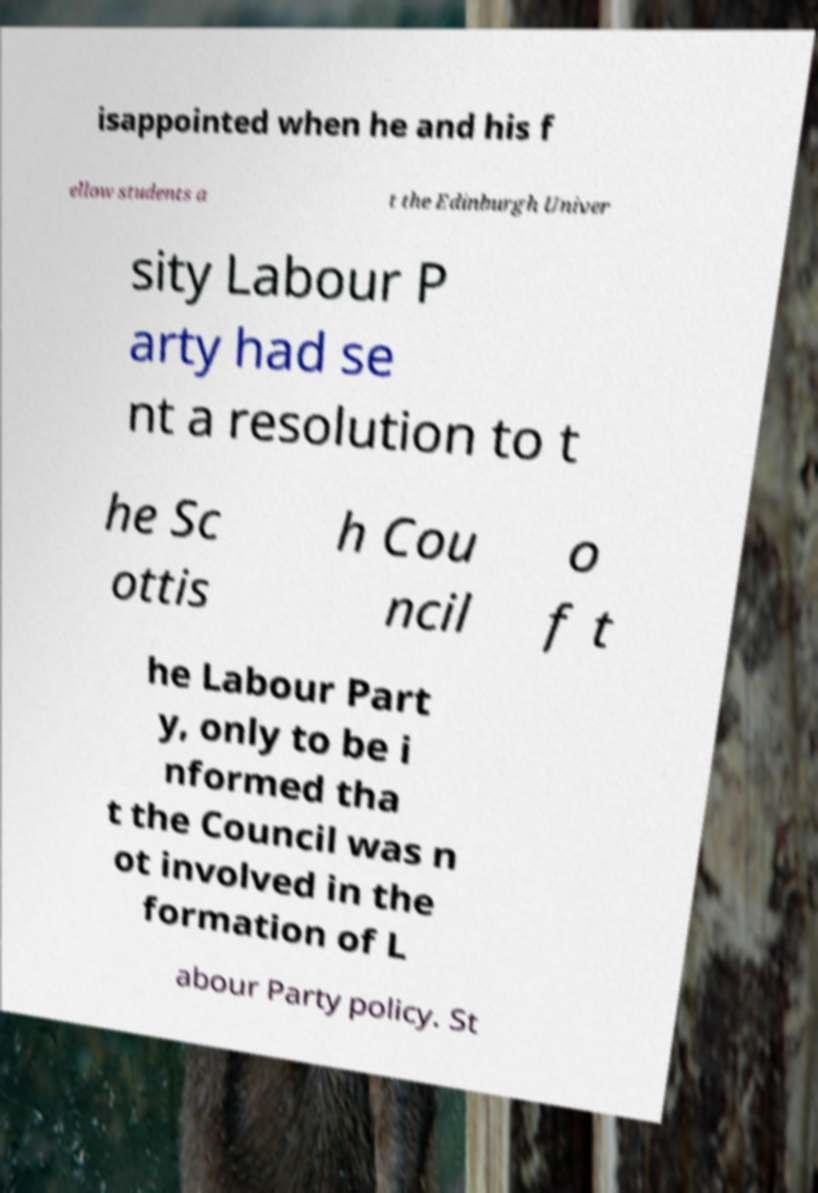Could you assist in decoding the text presented in this image and type it out clearly? isappointed when he and his f ellow students a t the Edinburgh Univer sity Labour P arty had se nt a resolution to t he Sc ottis h Cou ncil o f t he Labour Part y, only to be i nformed tha t the Council was n ot involved in the formation of L abour Party policy. St 